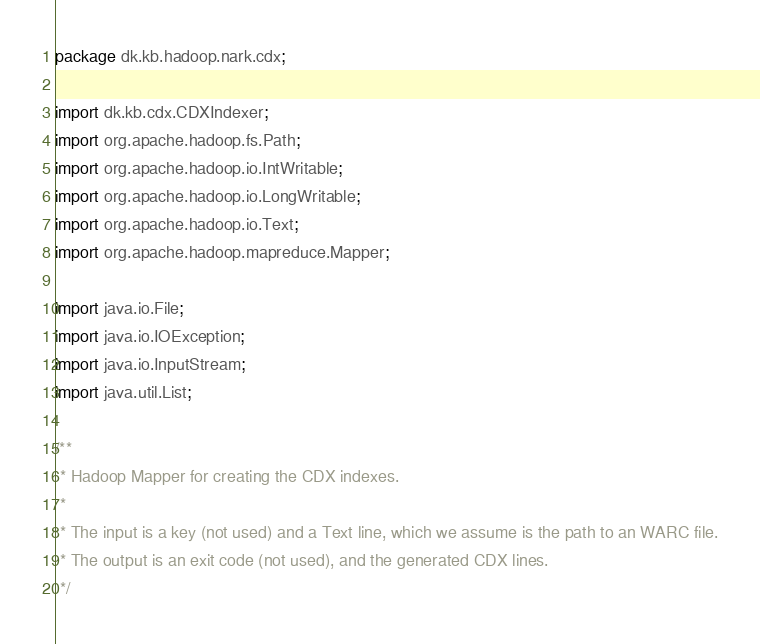Convert code to text. <code><loc_0><loc_0><loc_500><loc_500><_Java_>package dk.kb.hadoop.nark.cdx;

import dk.kb.cdx.CDXIndexer;
import org.apache.hadoop.fs.Path;
import org.apache.hadoop.io.IntWritable;
import org.apache.hadoop.io.LongWritable;
import org.apache.hadoop.io.Text;
import org.apache.hadoop.mapreduce.Mapper;

import java.io.File;
import java.io.IOException;
import java.io.InputStream;
import java.util.List;

/**
 * Hadoop Mapper for creating the CDX indexes.
 *
 * The input is a key (not used) and a Text line, which we assume is the path to an WARC file.
 * The output is an exit code (not used), and the generated CDX lines.
 */</code> 